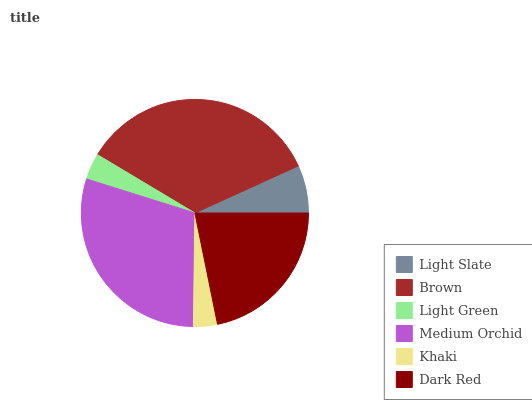Is Khaki the minimum?
Answer yes or no. Yes. Is Brown the maximum?
Answer yes or no. Yes. Is Light Green the minimum?
Answer yes or no. No. Is Light Green the maximum?
Answer yes or no. No. Is Brown greater than Light Green?
Answer yes or no. Yes. Is Light Green less than Brown?
Answer yes or no. Yes. Is Light Green greater than Brown?
Answer yes or no. No. Is Brown less than Light Green?
Answer yes or no. No. Is Dark Red the high median?
Answer yes or no. Yes. Is Light Slate the low median?
Answer yes or no. Yes. Is Brown the high median?
Answer yes or no. No. Is Medium Orchid the low median?
Answer yes or no. No. 